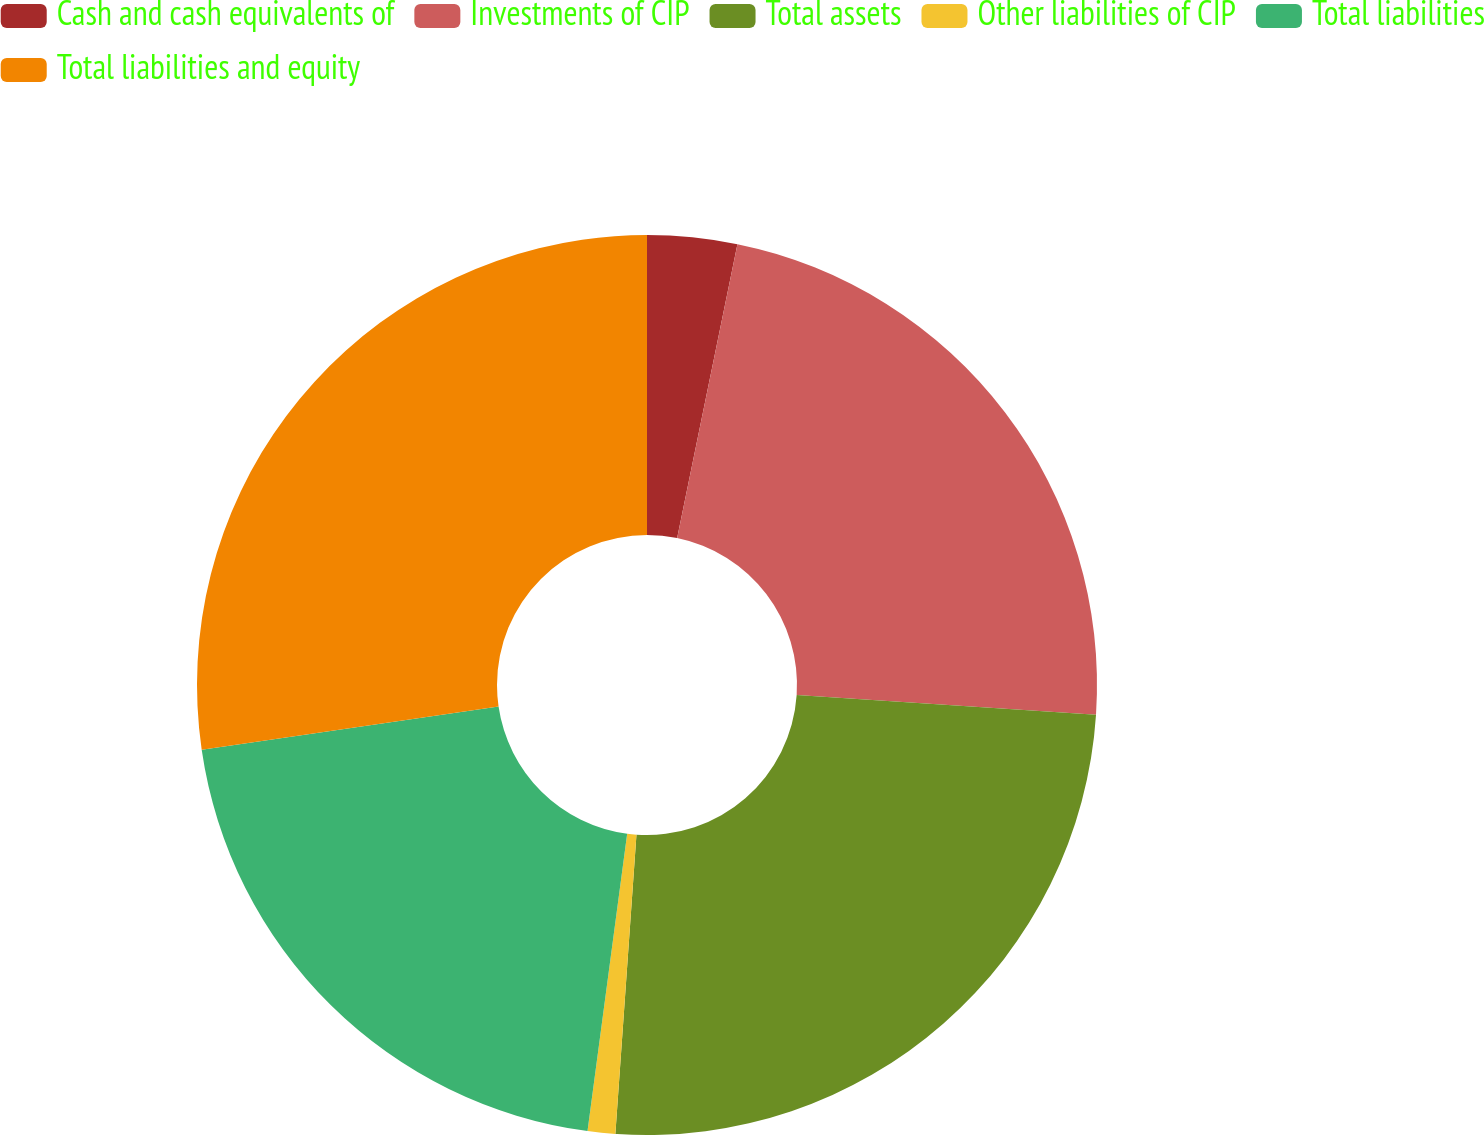Convert chart to OTSL. <chart><loc_0><loc_0><loc_500><loc_500><pie_chart><fcel>Cash and cash equivalents of<fcel>Investments of CIP<fcel>Total assets<fcel>Other liabilities of CIP<fcel>Total liabilities<fcel>Total liabilities and equity<nl><fcel>3.22%<fcel>22.83%<fcel>25.07%<fcel>0.99%<fcel>20.59%<fcel>27.3%<nl></chart> 